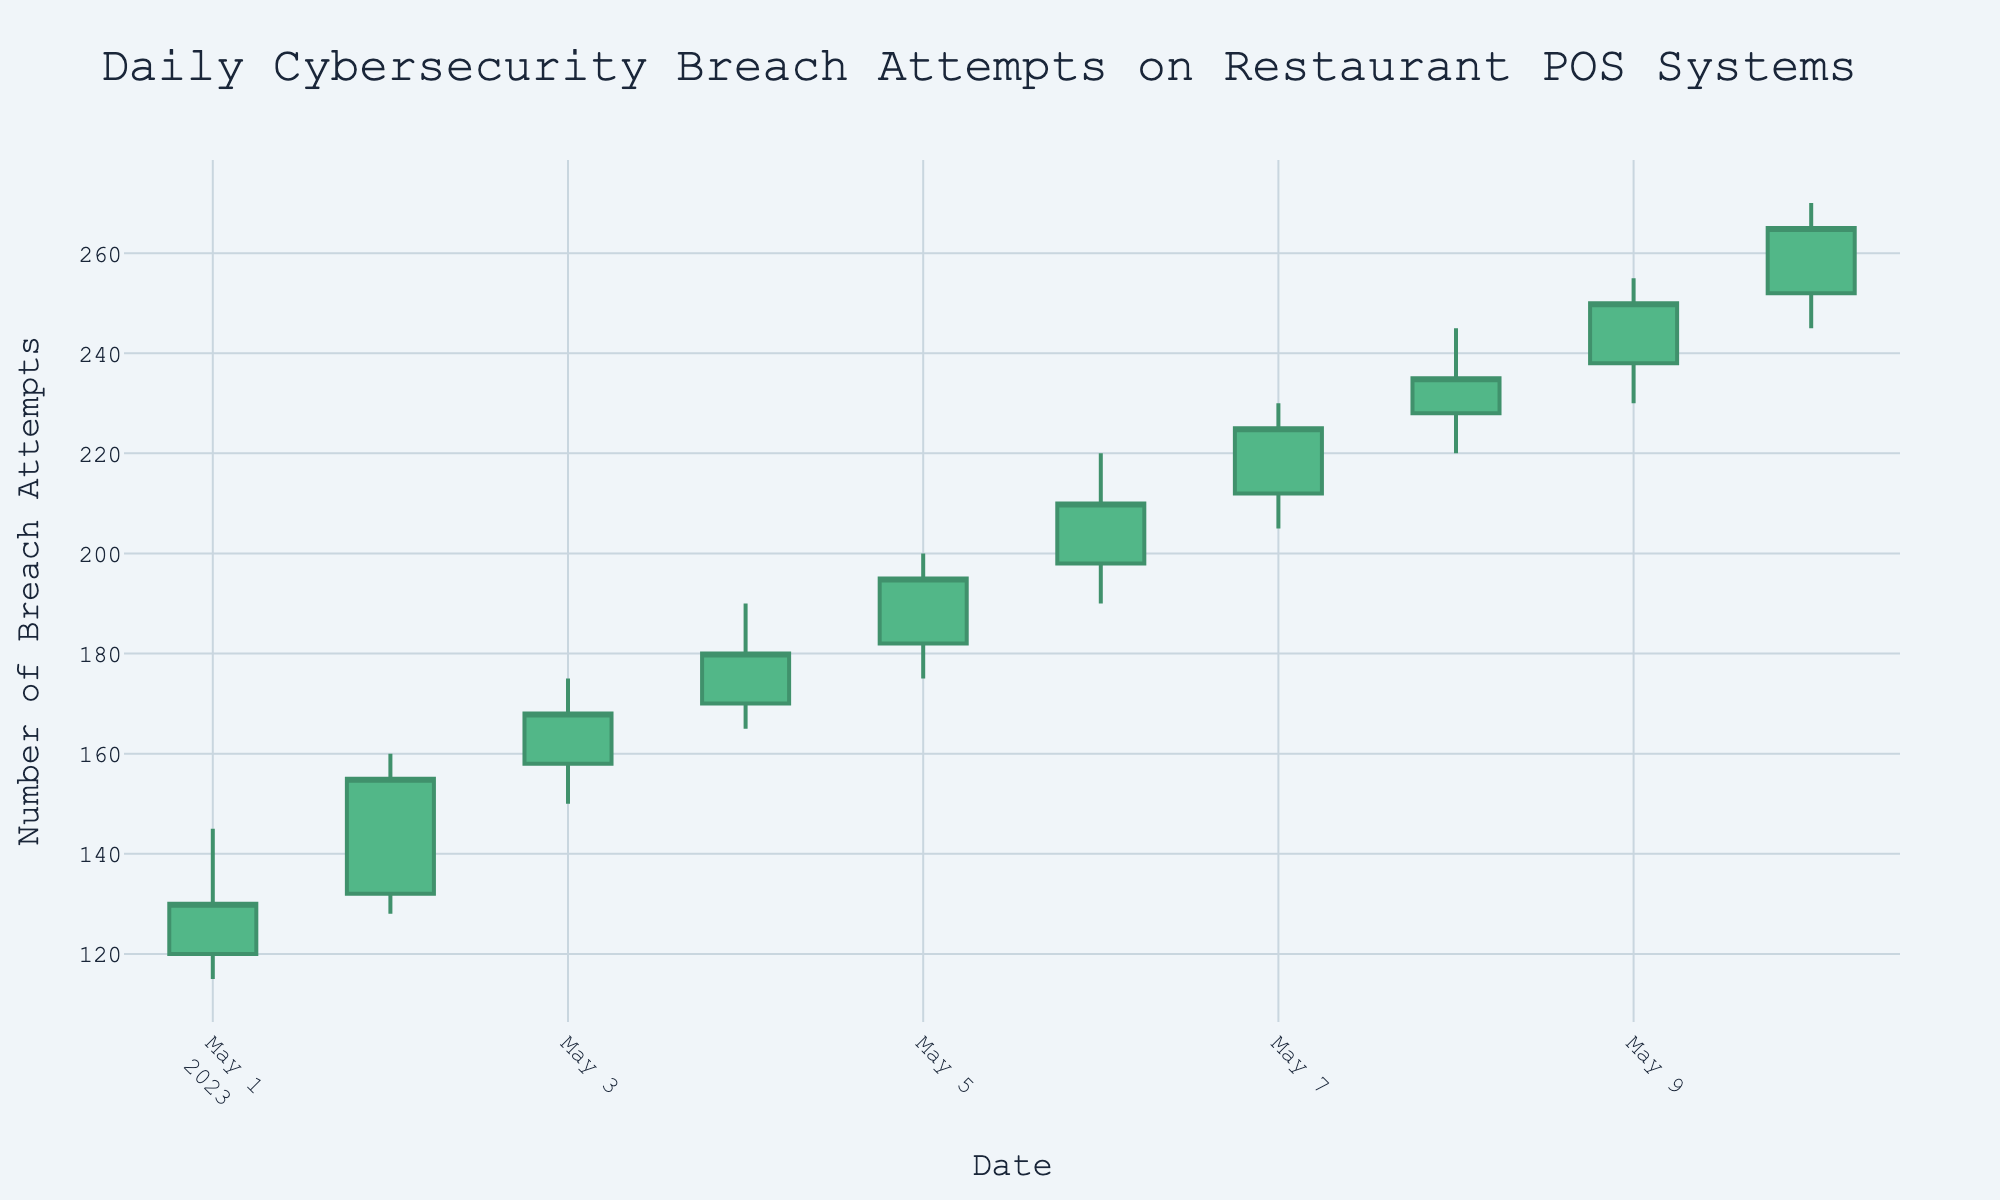what is the title of the chart? The title of the chart is located at the top and provides a description of the data. By reading the title, you can understand the subject being visualized.
Answer: Daily Cybersecurity Breach Attempts on Restaurant POS Systems how many data points are shown in this OHLC chart? Each data point represents a date with associated open, high, low, and close values. By counting the candlesticks, we can determine the number of days visualized.
Answer: 10 which day had the highest number of breach attempts? The highest number of breach attempts is represented by the highest "High" value on the y-axis. By looking for the tallest candlestick, we can identify the corresponding date.
Answer: 2023-05-10 what is the average closing value over the 10 days? To find the average closing value, sum all the closing values and divide by the number of days. Sum of closing values = 130 + 155 + 168 + 180 + 195 + 210 + 225 + 235 + 250 + 265. Number of days = 10. Thus, average = (130 + 155 + 168 + 180 + 195 + 210 + 225 + 235 + 250 + 265) / 10.
Answer: 201.3 did any day have a decrease in the number of breach attempts from open to close? A decrease from open to close is shown by a red candlestick. By identifying any red candlesticks, we can confirm whether there was a decrease.
Answer: No what is the difference between the highest and lowest breach attempts on 2023-05-06? The difference is found by subtracting the lowest value (Low) from the highest value (High) on that day. For 2023-05-06, High = 220 and Low = 190. Thus, difference = 220 - 190.
Answer: 30 which day showed the largest increase in breach attempts from open to close? The largest increase is identified by finding the candlestick with the greatest distance from the open to the close on the y-axis. This is indicated by the height of the green part of the candlestick.
Answer: 2023-05-09 what is the median closing value over the 10-day period? To find the median closing value, list the closing values in ascending order and find the middle value. If there is an even number of values, take the average of the two middle values. Ordered closing values: 130, 155, 168, 180, 195, 210, 225, 235, 250, 265. Median = (195 + 210) / 2.
Answer: 202.5 how does the breach attempt pattern on 2023-05-04 compare to 2023-05-07? To compare the patterns, observe the open, high, low, and close values for both days. Compare whether the values increased or decreased and by how much. 2023-05-04 shows open at 170 and close at 180. 2023-05-07 shows open at 212 and close at 225. Both days show an upward trend, but the increase is larger on 2023-05-07.
Answer: Both days show an increase, with a larger increase on 2023-05-07 